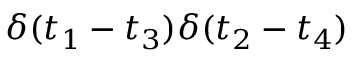Convert formula to latex. <formula><loc_0><loc_0><loc_500><loc_500>\delta ( t _ { 1 } - t _ { 3 } ) \delta ( t _ { 2 } - t _ { 4 } )</formula> 